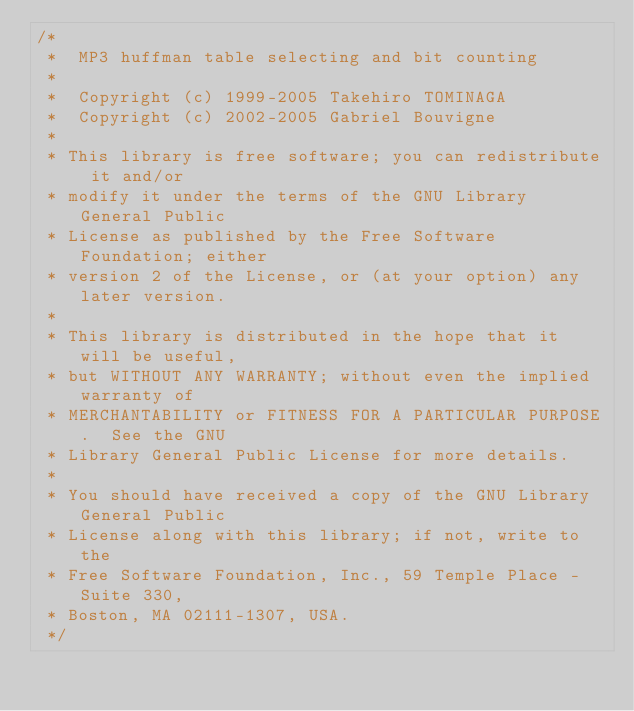Convert code to text. <code><loc_0><loc_0><loc_500><loc_500><_C_>/*
 *	MP3 huffman table selecting and bit counting
 *
 *	Copyright (c) 1999-2005 Takehiro TOMINAGA
 *	Copyright (c) 2002-2005 Gabriel Bouvigne
 *
 * This library is free software; you can redistribute it and/or
 * modify it under the terms of the GNU Library General Public
 * License as published by the Free Software Foundation; either
 * version 2 of the License, or (at your option) any later version.
 *
 * This library is distributed in the hope that it will be useful,
 * but WITHOUT ANY WARRANTY; without even the implied warranty of
 * MERCHANTABILITY or FITNESS FOR A PARTICULAR PURPOSE.	 See the GNU
 * Library General Public License for more details.
 *
 * You should have received a copy of the GNU Library General Public
 * License along with this library; if not, write to the
 * Free Software Foundation, Inc., 59 Temple Place - Suite 330,
 * Boston, MA 02111-1307, USA.
 */
</code> 